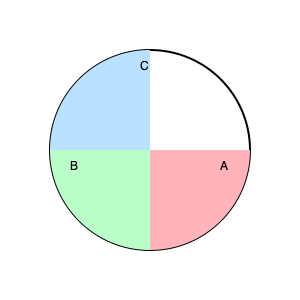As a junior civil servant working on budget transparency, you're presented with a pie chart representing the allocation of resources for a new government initiative. The chart is divided into three sections: A, B, and C. Estimate the percentage of the total budget that sections A and B combined represent. To estimate the combined percentage of sections A and B, we need to follow these steps:

1. Observe that the pie chart is divided into three sections: A, B, and C.

2. Estimate the size of each section:
   - Section A (pink) appears to cover about 90° or 1/4 of the circle.
   - Section B (green) appears to cover about 135° or 3/8 of the circle.
   - Section C (blue) covers the remaining 135° or 3/8 of the circle.

3. Calculate the percentage for each section:
   - Section A: $\frac{1}{4} \times 100\% = 25\%$
   - Section B: $\frac{3}{8} \times 100\% = 37.5\%$

4. Sum the percentages of sections A and B:
   $25\% + 37.5\% = 62.5\%$

5. Round to the nearest whole percentage:
   $62.5\%$ rounds to $63\%$

Therefore, sections A and B combined represent approximately 63% of the total budget.
Answer: 63% 